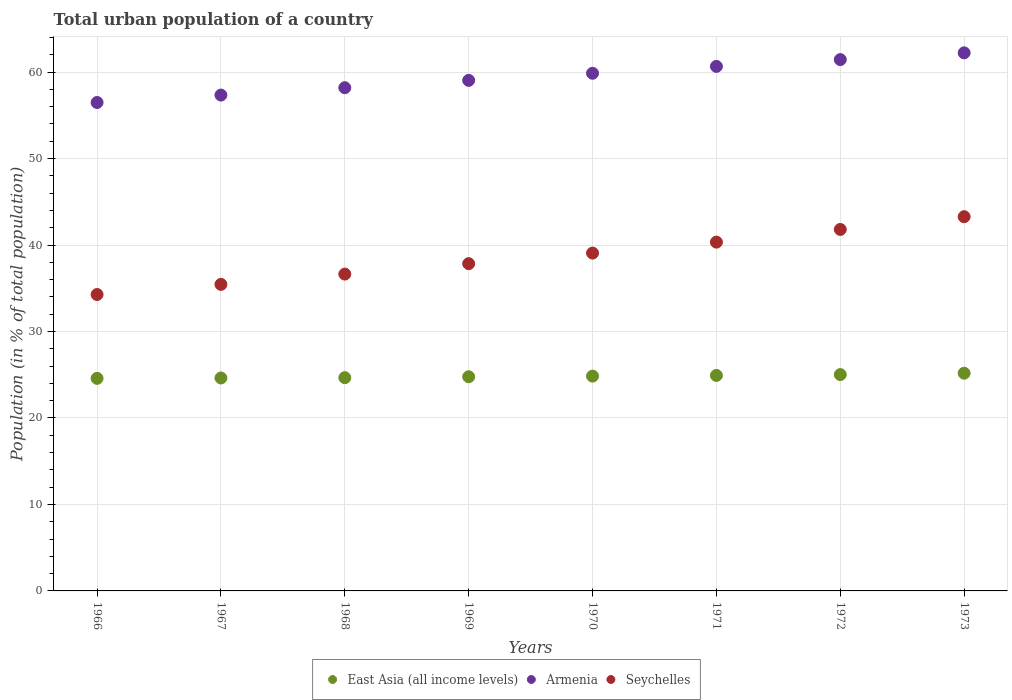How many different coloured dotlines are there?
Ensure brevity in your answer.  3. What is the urban population in Armenia in 1968?
Ensure brevity in your answer.  58.2. Across all years, what is the maximum urban population in Armenia?
Your answer should be very brief. 62.23. Across all years, what is the minimum urban population in Armenia?
Your answer should be compact. 56.48. In which year was the urban population in Seychelles maximum?
Ensure brevity in your answer.  1973. In which year was the urban population in Armenia minimum?
Your response must be concise. 1966. What is the total urban population in Seychelles in the graph?
Your answer should be compact. 308.7. What is the difference between the urban population in Seychelles in 1971 and that in 1972?
Give a very brief answer. -1.46. What is the difference between the urban population in Armenia in 1971 and the urban population in East Asia (all income levels) in 1968?
Offer a very short reply. 35.99. What is the average urban population in Seychelles per year?
Provide a succinct answer. 38.59. In the year 1970, what is the difference between the urban population in Seychelles and urban population in East Asia (all income levels)?
Offer a terse response. 14.23. In how many years, is the urban population in Seychelles greater than 48 %?
Your answer should be very brief. 0. What is the ratio of the urban population in Seychelles in 1967 to that in 1969?
Ensure brevity in your answer.  0.94. Is the urban population in Armenia in 1970 less than that in 1972?
Provide a succinct answer. Yes. What is the difference between the highest and the second highest urban population in Seychelles?
Your answer should be compact. 1.48. What is the difference between the highest and the lowest urban population in East Asia (all income levels)?
Make the answer very short. 0.59. In how many years, is the urban population in East Asia (all income levels) greater than the average urban population in East Asia (all income levels) taken over all years?
Your response must be concise. 4. Is the urban population in Seychelles strictly greater than the urban population in Armenia over the years?
Your response must be concise. No. Is the urban population in East Asia (all income levels) strictly less than the urban population in Armenia over the years?
Ensure brevity in your answer.  Yes. How many dotlines are there?
Provide a succinct answer. 3. How many years are there in the graph?
Your answer should be very brief. 8. What is the difference between two consecutive major ticks on the Y-axis?
Offer a terse response. 10. Does the graph contain any zero values?
Offer a terse response. No. How many legend labels are there?
Offer a very short reply. 3. What is the title of the graph?
Your response must be concise. Total urban population of a country. What is the label or title of the X-axis?
Provide a short and direct response. Years. What is the label or title of the Y-axis?
Offer a very short reply. Population (in % of total population). What is the Population (in % of total population) in East Asia (all income levels) in 1966?
Ensure brevity in your answer.  24.58. What is the Population (in % of total population) in Armenia in 1966?
Your response must be concise. 56.48. What is the Population (in % of total population) in Seychelles in 1966?
Give a very brief answer. 34.28. What is the Population (in % of total population) in East Asia (all income levels) in 1967?
Ensure brevity in your answer.  24.63. What is the Population (in % of total population) of Armenia in 1967?
Ensure brevity in your answer.  57.34. What is the Population (in % of total population) in Seychelles in 1967?
Your response must be concise. 35.45. What is the Population (in % of total population) in East Asia (all income levels) in 1968?
Provide a short and direct response. 24.66. What is the Population (in % of total population) in Armenia in 1968?
Keep it short and to the point. 58.2. What is the Population (in % of total population) in Seychelles in 1968?
Your answer should be compact. 36.64. What is the Population (in % of total population) of East Asia (all income levels) in 1969?
Provide a succinct answer. 24.77. What is the Population (in % of total population) of Armenia in 1969?
Provide a short and direct response. 59.04. What is the Population (in % of total population) of Seychelles in 1969?
Provide a succinct answer. 37.85. What is the Population (in % of total population) in East Asia (all income levels) in 1970?
Give a very brief answer. 24.84. What is the Population (in % of total population) of Armenia in 1970?
Offer a very short reply. 59.86. What is the Population (in % of total population) in Seychelles in 1970?
Ensure brevity in your answer.  39.07. What is the Population (in % of total population) of East Asia (all income levels) in 1971?
Provide a short and direct response. 24.92. What is the Population (in % of total population) of Armenia in 1971?
Ensure brevity in your answer.  60.66. What is the Population (in % of total population) in Seychelles in 1971?
Offer a terse response. 40.34. What is the Population (in % of total population) of East Asia (all income levels) in 1972?
Keep it short and to the point. 25.02. What is the Population (in % of total population) in Armenia in 1972?
Your response must be concise. 61.45. What is the Population (in % of total population) of Seychelles in 1972?
Give a very brief answer. 41.8. What is the Population (in % of total population) of East Asia (all income levels) in 1973?
Provide a succinct answer. 25.18. What is the Population (in % of total population) in Armenia in 1973?
Your answer should be compact. 62.23. What is the Population (in % of total population) of Seychelles in 1973?
Offer a terse response. 43.28. Across all years, what is the maximum Population (in % of total population) in East Asia (all income levels)?
Your response must be concise. 25.18. Across all years, what is the maximum Population (in % of total population) of Armenia?
Provide a short and direct response. 62.23. Across all years, what is the maximum Population (in % of total population) of Seychelles?
Your answer should be compact. 43.28. Across all years, what is the minimum Population (in % of total population) of East Asia (all income levels)?
Offer a very short reply. 24.58. Across all years, what is the minimum Population (in % of total population) in Armenia?
Make the answer very short. 56.48. Across all years, what is the minimum Population (in % of total population) of Seychelles?
Make the answer very short. 34.28. What is the total Population (in % of total population) in East Asia (all income levels) in the graph?
Your answer should be compact. 198.6. What is the total Population (in % of total population) of Armenia in the graph?
Offer a terse response. 475.25. What is the total Population (in % of total population) of Seychelles in the graph?
Your answer should be very brief. 308.7. What is the difference between the Population (in % of total population) of East Asia (all income levels) in 1966 and that in 1967?
Provide a succinct answer. -0.04. What is the difference between the Population (in % of total population) in Armenia in 1966 and that in 1967?
Provide a succinct answer. -0.86. What is the difference between the Population (in % of total population) of Seychelles in 1966 and that in 1967?
Your response must be concise. -1.17. What is the difference between the Population (in % of total population) of East Asia (all income levels) in 1966 and that in 1968?
Make the answer very short. -0.08. What is the difference between the Population (in % of total population) of Armenia in 1966 and that in 1968?
Give a very brief answer. -1.71. What is the difference between the Population (in % of total population) of Seychelles in 1966 and that in 1968?
Provide a succinct answer. -2.36. What is the difference between the Population (in % of total population) of East Asia (all income levels) in 1966 and that in 1969?
Make the answer very short. -0.19. What is the difference between the Population (in % of total population) of Armenia in 1966 and that in 1969?
Offer a very short reply. -2.56. What is the difference between the Population (in % of total population) in Seychelles in 1966 and that in 1969?
Your response must be concise. -3.57. What is the difference between the Population (in % of total population) in East Asia (all income levels) in 1966 and that in 1970?
Your answer should be very brief. -0.26. What is the difference between the Population (in % of total population) of Armenia in 1966 and that in 1970?
Keep it short and to the point. -3.38. What is the difference between the Population (in % of total population) in Seychelles in 1966 and that in 1970?
Your answer should be very brief. -4.79. What is the difference between the Population (in % of total population) in East Asia (all income levels) in 1966 and that in 1971?
Make the answer very short. -0.34. What is the difference between the Population (in % of total population) of Armenia in 1966 and that in 1971?
Your response must be concise. -4.17. What is the difference between the Population (in % of total population) in Seychelles in 1966 and that in 1971?
Provide a short and direct response. -6.06. What is the difference between the Population (in % of total population) of East Asia (all income levels) in 1966 and that in 1972?
Provide a short and direct response. -0.44. What is the difference between the Population (in % of total population) in Armenia in 1966 and that in 1972?
Provide a succinct answer. -4.96. What is the difference between the Population (in % of total population) in Seychelles in 1966 and that in 1972?
Provide a short and direct response. -7.53. What is the difference between the Population (in % of total population) of East Asia (all income levels) in 1966 and that in 1973?
Offer a very short reply. -0.59. What is the difference between the Population (in % of total population) of Armenia in 1966 and that in 1973?
Make the answer very short. -5.74. What is the difference between the Population (in % of total population) of East Asia (all income levels) in 1967 and that in 1968?
Make the answer very short. -0.04. What is the difference between the Population (in % of total population) of Armenia in 1967 and that in 1968?
Your response must be concise. -0.85. What is the difference between the Population (in % of total population) of Seychelles in 1967 and that in 1968?
Provide a succinct answer. -1.19. What is the difference between the Population (in % of total population) of East Asia (all income levels) in 1967 and that in 1969?
Your answer should be compact. -0.14. What is the difference between the Population (in % of total population) in Armenia in 1967 and that in 1969?
Your answer should be compact. -1.7. What is the difference between the Population (in % of total population) of Seychelles in 1967 and that in 1969?
Provide a succinct answer. -2.4. What is the difference between the Population (in % of total population) in East Asia (all income levels) in 1967 and that in 1970?
Keep it short and to the point. -0.21. What is the difference between the Population (in % of total population) of Armenia in 1967 and that in 1970?
Ensure brevity in your answer.  -2.52. What is the difference between the Population (in % of total population) in Seychelles in 1967 and that in 1970?
Provide a succinct answer. -3.62. What is the difference between the Population (in % of total population) of East Asia (all income levels) in 1967 and that in 1971?
Your answer should be compact. -0.29. What is the difference between the Population (in % of total population) of Armenia in 1967 and that in 1971?
Provide a succinct answer. -3.32. What is the difference between the Population (in % of total population) of Seychelles in 1967 and that in 1971?
Offer a terse response. -4.89. What is the difference between the Population (in % of total population) in East Asia (all income levels) in 1967 and that in 1972?
Provide a succinct answer. -0.39. What is the difference between the Population (in % of total population) of Armenia in 1967 and that in 1972?
Your answer should be very brief. -4.1. What is the difference between the Population (in % of total population) in Seychelles in 1967 and that in 1972?
Your answer should be very brief. -6.35. What is the difference between the Population (in % of total population) of East Asia (all income levels) in 1967 and that in 1973?
Make the answer very short. -0.55. What is the difference between the Population (in % of total population) in Armenia in 1967 and that in 1973?
Provide a succinct answer. -4.88. What is the difference between the Population (in % of total population) of Seychelles in 1967 and that in 1973?
Your answer should be compact. -7.83. What is the difference between the Population (in % of total population) of East Asia (all income levels) in 1968 and that in 1969?
Make the answer very short. -0.1. What is the difference between the Population (in % of total population) of Armenia in 1968 and that in 1969?
Give a very brief answer. -0.85. What is the difference between the Population (in % of total population) in Seychelles in 1968 and that in 1969?
Provide a succinct answer. -1.21. What is the difference between the Population (in % of total population) in East Asia (all income levels) in 1968 and that in 1970?
Make the answer very short. -0.18. What is the difference between the Population (in % of total population) of Armenia in 1968 and that in 1970?
Your response must be concise. -1.67. What is the difference between the Population (in % of total population) of Seychelles in 1968 and that in 1970?
Your response must be concise. -2.43. What is the difference between the Population (in % of total population) in East Asia (all income levels) in 1968 and that in 1971?
Provide a short and direct response. -0.26. What is the difference between the Population (in % of total population) in Armenia in 1968 and that in 1971?
Offer a very short reply. -2.46. What is the difference between the Population (in % of total population) in Seychelles in 1968 and that in 1971?
Ensure brevity in your answer.  -3.7. What is the difference between the Population (in % of total population) in East Asia (all income levels) in 1968 and that in 1972?
Make the answer very short. -0.36. What is the difference between the Population (in % of total population) in Armenia in 1968 and that in 1972?
Your answer should be compact. -3.25. What is the difference between the Population (in % of total population) of Seychelles in 1968 and that in 1972?
Your answer should be compact. -5.16. What is the difference between the Population (in % of total population) of East Asia (all income levels) in 1968 and that in 1973?
Give a very brief answer. -0.51. What is the difference between the Population (in % of total population) of Armenia in 1968 and that in 1973?
Your answer should be compact. -4.03. What is the difference between the Population (in % of total population) of Seychelles in 1968 and that in 1973?
Your answer should be very brief. -6.64. What is the difference between the Population (in % of total population) in East Asia (all income levels) in 1969 and that in 1970?
Offer a terse response. -0.07. What is the difference between the Population (in % of total population) in Armenia in 1969 and that in 1970?
Provide a succinct answer. -0.82. What is the difference between the Population (in % of total population) of Seychelles in 1969 and that in 1970?
Your answer should be compact. -1.22. What is the difference between the Population (in % of total population) of East Asia (all income levels) in 1969 and that in 1971?
Your answer should be compact. -0.15. What is the difference between the Population (in % of total population) in Armenia in 1969 and that in 1971?
Your answer should be compact. -1.61. What is the difference between the Population (in % of total population) of Seychelles in 1969 and that in 1971?
Offer a very short reply. -2.49. What is the difference between the Population (in % of total population) in East Asia (all income levels) in 1969 and that in 1972?
Keep it short and to the point. -0.25. What is the difference between the Population (in % of total population) in Armenia in 1969 and that in 1972?
Your answer should be compact. -2.4. What is the difference between the Population (in % of total population) of Seychelles in 1969 and that in 1972?
Keep it short and to the point. -3.96. What is the difference between the Population (in % of total population) in East Asia (all income levels) in 1969 and that in 1973?
Make the answer very short. -0.41. What is the difference between the Population (in % of total population) of Armenia in 1969 and that in 1973?
Give a very brief answer. -3.18. What is the difference between the Population (in % of total population) of Seychelles in 1969 and that in 1973?
Provide a succinct answer. -5.43. What is the difference between the Population (in % of total population) of East Asia (all income levels) in 1970 and that in 1971?
Offer a terse response. -0.08. What is the difference between the Population (in % of total population) in Armenia in 1970 and that in 1971?
Your answer should be very brief. -0.79. What is the difference between the Population (in % of total population) in Seychelles in 1970 and that in 1971?
Keep it short and to the point. -1.27. What is the difference between the Population (in % of total population) of East Asia (all income levels) in 1970 and that in 1972?
Give a very brief answer. -0.18. What is the difference between the Population (in % of total population) in Armenia in 1970 and that in 1972?
Your response must be concise. -1.58. What is the difference between the Population (in % of total population) in Seychelles in 1970 and that in 1972?
Offer a very short reply. -2.73. What is the difference between the Population (in % of total population) in East Asia (all income levels) in 1970 and that in 1973?
Make the answer very short. -0.34. What is the difference between the Population (in % of total population) in Armenia in 1970 and that in 1973?
Make the answer very short. -2.36. What is the difference between the Population (in % of total population) in Seychelles in 1970 and that in 1973?
Give a very brief answer. -4.21. What is the difference between the Population (in % of total population) in East Asia (all income levels) in 1971 and that in 1972?
Offer a terse response. -0.1. What is the difference between the Population (in % of total population) of Armenia in 1971 and that in 1972?
Your answer should be compact. -0.79. What is the difference between the Population (in % of total population) of Seychelles in 1971 and that in 1972?
Make the answer very short. -1.47. What is the difference between the Population (in % of total population) of East Asia (all income levels) in 1971 and that in 1973?
Your answer should be compact. -0.25. What is the difference between the Population (in % of total population) in Armenia in 1971 and that in 1973?
Give a very brief answer. -1.57. What is the difference between the Population (in % of total population) of Seychelles in 1971 and that in 1973?
Give a very brief answer. -2.94. What is the difference between the Population (in % of total population) in East Asia (all income levels) in 1972 and that in 1973?
Your response must be concise. -0.16. What is the difference between the Population (in % of total population) in Armenia in 1972 and that in 1973?
Offer a very short reply. -0.78. What is the difference between the Population (in % of total population) of Seychelles in 1972 and that in 1973?
Offer a terse response. -1.48. What is the difference between the Population (in % of total population) in East Asia (all income levels) in 1966 and the Population (in % of total population) in Armenia in 1967?
Make the answer very short. -32.76. What is the difference between the Population (in % of total population) of East Asia (all income levels) in 1966 and the Population (in % of total population) of Seychelles in 1967?
Offer a terse response. -10.87. What is the difference between the Population (in % of total population) of Armenia in 1966 and the Population (in % of total population) of Seychelles in 1967?
Your response must be concise. 21.03. What is the difference between the Population (in % of total population) of East Asia (all income levels) in 1966 and the Population (in % of total population) of Armenia in 1968?
Make the answer very short. -33.61. What is the difference between the Population (in % of total population) of East Asia (all income levels) in 1966 and the Population (in % of total population) of Seychelles in 1968?
Your answer should be very brief. -12.06. What is the difference between the Population (in % of total population) of Armenia in 1966 and the Population (in % of total population) of Seychelles in 1968?
Your response must be concise. 19.84. What is the difference between the Population (in % of total population) of East Asia (all income levels) in 1966 and the Population (in % of total population) of Armenia in 1969?
Ensure brevity in your answer.  -34.46. What is the difference between the Population (in % of total population) in East Asia (all income levels) in 1966 and the Population (in % of total population) in Seychelles in 1969?
Your response must be concise. -13.26. What is the difference between the Population (in % of total population) of Armenia in 1966 and the Population (in % of total population) of Seychelles in 1969?
Give a very brief answer. 18.64. What is the difference between the Population (in % of total population) in East Asia (all income levels) in 1966 and the Population (in % of total population) in Armenia in 1970?
Ensure brevity in your answer.  -35.28. What is the difference between the Population (in % of total population) of East Asia (all income levels) in 1966 and the Population (in % of total population) of Seychelles in 1970?
Offer a terse response. -14.49. What is the difference between the Population (in % of total population) of Armenia in 1966 and the Population (in % of total population) of Seychelles in 1970?
Provide a short and direct response. 17.41. What is the difference between the Population (in % of total population) of East Asia (all income levels) in 1966 and the Population (in % of total population) of Armenia in 1971?
Give a very brief answer. -36.07. What is the difference between the Population (in % of total population) of East Asia (all income levels) in 1966 and the Population (in % of total population) of Seychelles in 1971?
Keep it short and to the point. -15.75. What is the difference between the Population (in % of total population) in Armenia in 1966 and the Population (in % of total population) in Seychelles in 1971?
Your response must be concise. 16.15. What is the difference between the Population (in % of total population) in East Asia (all income levels) in 1966 and the Population (in % of total population) in Armenia in 1972?
Give a very brief answer. -36.86. What is the difference between the Population (in % of total population) in East Asia (all income levels) in 1966 and the Population (in % of total population) in Seychelles in 1972?
Ensure brevity in your answer.  -17.22. What is the difference between the Population (in % of total population) of Armenia in 1966 and the Population (in % of total population) of Seychelles in 1972?
Give a very brief answer. 14.68. What is the difference between the Population (in % of total population) of East Asia (all income levels) in 1966 and the Population (in % of total population) of Armenia in 1973?
Your answer should be very brief. -37.64. What is the difference between the Population (in % of total population) in East Asia (all income levels) in 1966 and the Population (in % of total population) in Seychelles in 1973?
Offer a very short reply. -18.69. What is the difference between the Population (in % of total population) in Armenia in 1966 and the Population (in % of total population) in Seychelles in 1973?
Provide a short and direct response. 13.21. What is the difference between the Population (in % of total population) of East Asia (all income levels) in 1967 and the Population (in % of total population) of Armenia in 1968?
Your answer should be compact. -33.57. What is the difference between the Population (in % of total population) in East Asia (all income levels) in 1967 and the Population (in % of total population) in Seychelles in 1968?
Ensure brevity in your answer.  -12.01. What is the difference between the Population (in % of total population) of Armenia in 1967 and the Population (in % of total population) of Seychelles in 1968?
Offer a terse response. 20.7. What is the difference between the Population (in % of total population) in East Asia (all income levels) in 1967 and the Population (in % of total population) in Armenia in 1969?
Provide a short and direct response. -34.42. What is the difference between the Population (in % of total population) of East Asia (all income levels) in 1967 and the Population (in % of total population) of Seychelles in 1969?
Provide a succinct answer. -13.22. What is the difference between the Population (in % of total population) of Armenia in 1967 and the Population (in % of total population) of Seychelles in 1969?
Ensure brevity in your answer.  19.5. What is the difference between the Population (in % of total population) in East Asia (all income levels) in 1967 and the Population (in % of total population) in Armenia in 1970?
Make the answer very short. -35.24. What is the difference between the Population (in % of total population) of East Asia (all income levels) in 1967 and the Population (in % of total population) of Seychelles in 1970?
Provide a succinct answer. -14.44. What is the difference between the Population (in % of total population) of Armenia in 1967 and the Population (in % of total population) of Seychelles in 1970?
Keep it short and to the point. 18.27. What is the difference between the Population (in % of total population) in East Asia (all income levels) in 1967 and the Population (in % of total population) in Armenia in 1971?
Give a very brief answer. -36.03. What is the difference between the Population (in % of total population) of East Asia (all income levels) in 1967 and the Population (in % of total population) of Seychelles in 1971?
Make the answer very short. -15.71. What is the difference between the Population (in % of total population) of Armenia in 1967 and the Population (in % of total population) of Seychelles in 1971?
Your answer should be compact. 17. What is the difference between the Population (in % of total population) of East Asia (all income levels) in 1967 and the Population (in % of total population) of Armenia in 1972?
Make the answer very short. -36.82. What is the difference between the Population (in % of total population) in East Asia (all income levels) in 1967 and the Population (in % of total population) in Seychelles in 1972?
Your response must be concise. -17.18. What is the difference between the Population (in % of total population) in Armenia in 1967 and the Population (in % of total population) in Seychelles in 1972?
Provide a short and direct response. 15.54. What is the difference between the Population (in % of total population) in East Asia (all income levels) in 1967 and the Population (in % of total population) in Armenia in 1973?
Your response must be concise. -37.6. What is the difference between the Population (in % of total population) in East Asia (all income levels) in 1967 and the Population (in % of total population) in Seychelles in 1973?
Make the answer very short. -18.65. What is the difference between the Population (in % of total population) of Armenia in 1967 and the Population (in % of total population) of Seychelles in 1973?
Offer a very short reply. 14.06. What is the difference between the Population (in % of total population) of East Asia (all income levels) in 1968 and the Population (in % of total population) of Armenia in 1969?
Provide a succinct answer. -34.38. What is the difference between the Population (in % of total population) in East Asia (all income levels) in 1968 and the Population (in % of total population) in Seychelles in 1969?
Offer a terse response. -13.18. What is the difference between the Population (in % of total population) in Armenia in 1968 and the Population (in % of total population) in Seychelles in 1969?
Ensure brevity in your answer.  20.35. What is the difference between the Population (in % of total population) of East Asia (all income levels) in 1968 and the Population (in % of total population) of Armenia in 1970?
Your response must be concise. -35.2. What is the difference between the Population (in % of total population) of East Asia (all income levels) in 1968 and the Population (in % of total population) of Seychelles in 1970?
Your answer should be very brief. -14.41. What is the difference between the Population (in % of total population) in Armenia in 1968 and the Population (in % of total population) in Seychelles in 1970?
Your response must be concise. 19.13. What is the difference between the Population (in % of total population) of East Asia (all income levels) in 1968 and the Population (in % of total population) of Armenia in 1971?
Your answer should be very brief. -35.99. What is the difference between the Population (in % of total population) in East Asia (all income levels) in 1968 and the Population (in % of total population) in Seychelles in 1971?
Ensure brevity in your answer.  -15.67. What is the difference between the Population (in % of total population) of Armenia in 1968 and the Population (in % of total population) of Seychelles in 1971?
Provide a succinct answer. 17.86. What is the difference between the Population (in % of total population) in East Asia (all income levels) in 1968 and the Population (in % of total population) in Armenia in 1972?
Offer a very short reply. -36.78. What is the difference between the Population (in % of total population) in East Asia (all income levels) in 1968 and the Population (in % of total population) in Seychelles in 1972?
Make the answer very short. -17.14. What is the difference between the Population (in % of total population) of Armenia in 1968 and the Population (in % of total population) of Seychelles in 1972?
Provide a succinct answer. 16.39. What is the difference between the Population (in % of total population) of East Asia (all income levels) in 1968 and the Population (in % of total population) of Armenia in 1973?
Offer a terse response. -37.56. What is the difference between the Population (in % of total population) of East Asia (all income levels) in 1968 and the Population (in % of total population) of Seychelles in 1973?
Make the answer very short. -18.61. What is the difference between the Population (in % of total population) of Armenia in 1968 and the Population (in % of total population) of Seychelles in 1973?
Provide a succinct answer. 14.92. What is the difference between the Population (in % of total population) in East Asia (all income levels) in 1969 and the Population (in % of total population) in Armenia in 1970?
Ensure brevity in your answer.  -35.1. What is the difference between the Population (in % of total population) in East Asia (all income levels) in 1969 and the Population (in % of total population) in Seychelles in 1970?
Give a very brief answer. -14.3. What is the difference between the Population (in % of total population) of Armenia in 1969 and the Population (in % of total population) of Seychelles in 1970?
Ensure brevity in your answer.  19.97. What is the difference between the Population (in % of total population) in East Asia (all income levels) in 1969 and the Population (in % of total population) in Armenia in 1971?
Keep it short and to the point. -35.89. What is the difference between the Population (in % of total population) of East Asia (all income levels) in 1969 and the Population (in % of total population) of Seychelles in 1971?
Make the answer very short. -15.57. What is the difference between the Population (in % of total population) in Armenia in 1969 and the Population (in % of total population) in Seychelles in 1971?
Ensure brevity in your answer.  18.7. What is the difference between the Population (in % of total population) of East Asia (all income levels) in 1969 and the Population (in % of total population) of Armenia in 1972?
Your answer should be compact. -36.68. What is the difference between the Population (in % of total population) in East Asia (all income levels) in 1969 and the Population (in % of total population) in Seychelles in 1972?
Give a very brief answer. -17.03. What is the difference between the Population (in % of total population) in Armenia in 1969 and the Population (in % of total population) in Seychelles in 1972?
Offer a very short reply. 17.24. What is the difference between the Population (in % of total population) in East Asia (all income levels) in 1969 and the Population (in % of total population) in Armenia in 1973?
Ensure brevity in your answer.  -37.46. What is the difference between the Population (in % of total population) of East Asia (all income levels) in 1969 and the Population (in % of total population) of Seychelles in 1973?
Ensure brevity in your answer.  -18.51. What is the difference between the Population (in % of total population) in Armenia in 1969 and the Population (in % of total population) in Seychelles in 1973?
Your answer should be compact. 15.77. What is the difference between the Population (in % of total population) of East Asia (all income levels) in 1970 and the Population (in % of total population) of Armenia in 1971?
Provide a succinct answer. -35.82. What is the difference between the Population (in % of total population) in East Asia (all income levels) in 1970 and the Population (in % of total population) in Seychelles in 1971?
Provide a succinct answer. -15.5. What is the difference between the Population (in % of total population) in Armenia in 1970 and the Population (in % of total population) in Seychelles in 1971?
Provide a succinct answer. 19.53. What is the difference between the Population (in % of total population) of East Asia (all income levels) in 1970 and the Population (in % of total population) of Armenia in 1972?
Provide a succinct answer. -36.6. What is the difference between the Population (in % of total population) in East Asia (all income levels) in 1970 and the Population (in % of total population) in Seychelles in 1972?
Offer a very short reply. -16.96. What is the difference between the Population (in % of total population) in Armenia in 1970 and the Population (in % of total population) in Seychelles in 1972?
Your answer should be very brief. 18.06. What is the difference between the Population (in % of total population) of East Asia (all income levels) in 1970 and the Population (in % of total population) of Armenia in 1973?
Give a very brief answer. -37.38. What is the difference between the Population (in % of total population) of East Asia (all income levels) in 1970 and the Population (in % of total population) of Seychelles in 1973?
Ensure brevity in your answer.  -18.44. What is the difference between the Population (in % of total population) of Armenia in 1970 and the Population (in % of total population) of Seychelles in 1973?
Give a very brief answer. 16.59. What is the difference between the Population (in % of total population) of East Asia (all income levels) in 1971 and the Population (in % of total population) of Armenia in 1972?
Offer a very short reply. -36.52. What is the difference between the Population (in % of total population) in East Asia (all income levels) in 1971 and the Population (in % of total population) in Seychelles in 1972?
Offer a very short reply. -16.88. What is the difference between the Population (in % of total population) in Armenia in 1971 and the Population (in % of total population) in Seychelles in 1972?
Ensure brevity in your answer.  18.86. What is the difference between the Population (in % of total population) of East Asia (all income levels) in 1971 and the Population (in % of total population) of Armenia in 1973?
Provide a succinct answer. -37.3. What is the difference between the Population (in % of total population) of East Asia (all income levels) in 1971 and the Population (in % of total population) of Seychelles in 1973?
Make the answer very short. -18.36. What is the difference between the Population (in % of total population) in Armenia in 1971 and the Population (in % of total population) in Seychelles in 1973?
Offer a terse response. 17.38. What is the difference between the Population (in % of total population) in East Asia (all income levels) in 1972 and the Population (in % of total population) in Armenia in 1973?
Your answer should be very brief. -37.21. What is the difference between the Population (in % of total population) of East Asia (all income levels) in 1972 and the Population (in % of total population) of Seychelles in 1973?
Offer a very short reply. -18.26. What is the difference between the Population (in % of total population) of Armenia in 1972 and the Population (in % of total population) of Seychelles in 1973?
Your response must be concise. 18.17. What is the average Population (in % of total population) of East Asia (all income levels) per year?
Offer a terse response. 24.82. What is the average Population (in % of total population) of Armenia per year?
Ensure brevity in your answer.  59.41. What is the average Population (in % of total population) of Seychelles per year?
Make the answer very short. 38.59. In the year 1966, what is the difference between the Population (in % of total population) of East Asia (all income levels) and Population (in % of total population) of Armenia?
Keep it short and to the point. -31.9. In the year 1966, what is the difference between the Population (in % of total population) in East Asia (all income levels) and Population (in % of total population) in Seychelles?
Keep it short and to the point. -9.69. In the year 1966, what is the difference between the Population (in % of total population) in Armenia and Population (in % of total population) in Seychelles?
Your answer should be very brief. 22.21. In the year 1967, what is the difference between the Population (in % of total population) of East Asia (all income levels) and Population (in % of total population) of Armenia?
Provide a short and direct response. -32.71. In the year 1967, what is the difference between the Population (in % of total population) in East Asia (all income levels) and Population (in % of total population) in Seychelles?
Offer a very short reply. -10.82. In the year 1967, what is the difference between the Population (in % of total population) in Armenia and Population (in % of total population) in Seychelles?
Offer a terse response. 21.89. In the year 1968, what is the difference between the Population (in % of total population) in East Asia (all income levels) and Population (in % of total population) in Armenia?
Your answer should be very brief. -33.53. In the year 1968, what is the difference between the Population (in % of total population) of East Asia (all income levels) and Population (in % of total population) of Seychelles?
Provide a short and direct response. -11.98. In the year 1968, what is the difference between the Population (in % of total population) in Armenia and Population (in % of total population) in Seychelles?
Make the answer very short. 21.55. In the year 1969, what is the difference between the Population (in % of total population) of East Asia (all income levels) and Population (in % of total population) of Armenia?
Make the answer very short. -34.27. In the year 1969, what is the difference between the Population (in % of total population) of East Asia (all income levels) and Population (in % of total population) of Seychelles?
Ensure brevity in your answer.  -13.08. In the year 1969, what is the difference between the Population (in % of total population) of Armenia and Population (in % of total population) of Seychelles?
Give a very brief answer. 21.2. In the year 1970, what is the difference between the Population (in % of total population) of East Asia (all income levels) and Population (in % of total population) of Armenia?
Make the answer very short. -35.02. In the year 1970, what is the difference between the Population (in % of total population) of East Asia (all income levels) and Population (in % of total population) of Seychelles?
Offer a terse response. -14.23. In the year 1970, what is the difference between the Population (in % of total population) in Armenia and Population (in % of total population) in Seychelles?
Offer a very short reply. 20.8. In the year 1971, what is the difference between the Population (in % of total population) of East Asia (all income levels) and Population (in % of total population) of Armenia?
Offer a very short reply. -35.74. In the year 1971, what is the difference between the Population (in % of total population) of East Asia (all income levels) and Population (in % of total population) of Seychelles?
Your response must be concise. -15.42. In the year 1971, what is the difference between the Population (in % of total population) of Armenia and Population (in % of total population) of Seychelles?
Provide a succinct answer. 20.32. In the year 1972, what is the difference between the Population (in % of total population) of East Asia (all income levels) and Population (in % of total population) of Armenia?
Give a very brief answer. -36.43. In the year 1972, what is the difference between the Population (in % of total population) in East Asia (all income levels) and Population (in % of total population) in Seychelles?
Give a very brief answer. -16.78. In the year 1972, what is the difference between the Population (in % of total population) of Armenia and Population (in % of total population) of Seychelles?
Give a very brief answer. 19.64. In the year 1973, what is the difference between the Population (in % of total population) in East Asia (all income levels) and Population (in % of total population) in Armenia?
Your answer should be very brief. -37.05. In the year 1973, what is the difference between the Population (in % of total population) of East Asia (all income levels) and Population (in % of total population) of Seychelles?
Your answer should be very brief. -18.1. In the year 1973, what is the difference between the Population (in % of total population) of Armenia and Population (in % of total population) of Seychelles?
Your response must be concise. 18.95. What is the ratio of the Population (in % of total population) in Armenia in 1966 to that in 1967?
Make the answer very short. 0.98. What is the ratio of the Population (in % of total population) in Seychelles in 1966 to that in 1967?
Make the answer very short. 0.97. What is the ratio of the Population (in % of total population) in Armenia in 1966 to that in 1968?
Ensure brevity in your answer.  0.97. What is the ratio of the Population (in % of total population) in Seychelles in 1966 to that in 1968?
Keep it short and to the point. 0.94. What is the ratio of the Population (in % of total population) of East Asia (all income levels) in 1966 to that in 1969?
Offer a terse response. 0.99. What is the ratio of the Population (in % of total population) of Armenia in 1966 to that in 1969?
Your answer should be compact. 0.96. What is the ratio of the Population (in % of total population) of Seychelles in 1966 to that in 1969?
Ensure brevity in your answer.  0.91. What is the ratio of the Population (in % of total population) of East Asia (all income levels) in 1966 to that in 1970?
Give a very brief answer. 0.99. What is the ratio of the Population (in % of total population) in Armenia in 1966 to that in 1970?
Make the answer very short. 0.94. What is the ratio of the Population (in % of total population) in Seychelles in 1966 to that in 1970?
Your answer should be very brief. 0.88. What is the ratio of the Population (in % of total population) in East Asia (all income levels) in 1966 to that in 1971?
Give a very brief answer. 0.99. What is the ratio of the Population (in % of total population) of Armenia in 1966 to that in 1971?
Provide a short and direct response. 0.93. What is the ratio of the Population (in % of total population) in Seychelles in 1966 to that in 1971?
Your answer should be very brief. 0.85. What is the ratio of the Population (in % of total population) of East Asia (all income levels) in 1966 to that in 1972?
Keep it short and to the point. 0.98. What is the ratio of the Population (in % of total population) of Armenia in 1966 to that in 1972?
Offer a very short reply. 0.92. What is the ratio of the Population (in % of total population) in Seychelles in 1966 to that in 1972?
Your response must be concise. 0.82. What is the ratio of the Population (in % of total population) of East Asia (all income levels) in 1966 to that in 1973?
Your answer should be compact. 0.98. What is the ratio of the Population (in % of total population) in Armenia in 1966 to that in 1973?
Offer a terse response. 0.91. What is the ratio of the Population (in % of total population) in Seychelles in 1966 to that in 1973?
Keep it short and to the point. 0.79. What is the ratio of the Population (in % of total population) in East Asia (all income levels) in 1967 to that in 1968?
Provide a short and direct response. 1. What is the ratio of the Population (in % of total population) of Armenia in 1967 to that in 1968?
Provide a short and direct response. 0.99. What is the ratio of the Population (in % of total population) of Seychelles in 1967 to that in 1968?
Offer a terse response. 0.97. What is the ratio of the Population (in % of total population) in Armenia in 1967 to that in 1969?
Your answer should be very brief. 0.97. What is the ratio of the Population (in % of total population) of Seychelles in 1967 to that in 1969?
Provide a succinct answer. 0.94. What is the ratio of the Population (in % of total population) of East Asia (all income levels) in 1967 to that in 1970?
Offer a terse response. 0.99. What is the ratio of the Population (in % of total population) in Armenia in 1967 to that in 1970?
Give a very brief answer. 0.96. What is the ratio of the Population (in % of total population) of Seychelles in 1967 to that in 1970?
Give a very brief answer. 0.91. What is the ratio of the Population (in % of total population) of Armenia in 1967 to that in 1971?
Your answer should be very brief. 0.95. What is the ratio of the Population (in % of total population) in Seychelles in 1967 to that in 1971?
Give a very brief answer. 0.88. What is the ratio of the Population (in % of total population) in East Asia (all income levels) in 1967 to that in 1972?
Provide a succinct answer. 0.98. What is the ratio of the Population (in % of total population) in Armenia in 1967 to that in 1972?
Ensure brevity in your answer.  0.93. What is the ratio of the Population (in % of total population) of Seychelles in 1967 to that in 1972?
Give a very brief answer. 0.85. What is the ratio of the Population (in % of total population) of East Asia (all income levels) in 1967 to that in 1973?
Provide a succinct answer. 0.98. What is the ratio of the Population (in % of total population) in Armenia in 1967 to that in 1973?
Provide a short and direct response. 0.92. What is the ratio of the Population (in % of total population) in Seychelles in 1967 to that in 1973?
Provide a short and direct response. 0.82. What is the ratio of the Population (in % of total population) of Armenia in 1968 to that in 1969?
Give a very brief answer. 0.99. What is the ratio of the Population (in % of total population) of Seychelles in 1968 to that in 1969?
Give a very brief answer. 0.97. What is the ratio of the Population (in % of total population) in Armenia in 1968 to that in 1970?
Make the answer very short. 0.97. What is the ratio of the Population (in % of total population) in Seychelles in 1968 to that in 1970?
Keep it short and to the point. 0.94. What is the ratio of the Population (in % of total population) of East Asia (all income levels) in 1968 to that in 1971?
Ensure brevity in your answer.  0.99. What is the ratio of the Population (in % of total population) of Armenia in 1968 to that in 1971?
Your answer should be compact. 0.96. What is the ratio of the Population (in % of total population) in Seychelles in 1968 to that in 1971?
Give a very brief answer. 0.91. What is the ratio of the Population (in % of total population) of East Asia (all income levels) in 1968 to that in 1972?
Give a very brief answer. 0.99. What is the ratio of the Population (in % of total population) in Armenia in 1968 to that in 1972?
Give a very brief answer. 0.95. What is the ratio of the Population (in % of total population) of Seychelles in 1968 to that in 1972?
Your answer should be very brief. 0.88. What is the ratio of the Population (in % of total population) of East Asia (all income levels) in 1968 to that in 1973?
Keep it short and to the point. 0.98. What is the ratio of the Population (in % of total population) of Armenia in 1968 to that in 1973?
Provide a short and direct response. 0.94. What is the ratio of the Population (in % of total population) in Seychelles in 1968 to that in 1973?
Offer a terse response. 0.85. What is the ratio of the Population (in % of total population) of East Asia (all income levels) in 1969 to that in 1970?
Your response must be concise. 1. What is the ratio of the Population (in % of total population) in Armenia in 1969 to that in 1970?
Your response must be concise. 0.99. What is the ratio of the Population (in % of total population) in Seychelles in 1969 to that in 1970?
Provide a short and direct response. 0.97. What is the ratio of the Population (in % of total population) in Armenia in 1969 to that in 1971?
Your response must be concise. 0.97. What is the ratio of the Population (in % of total population) of Seychelles in 1969 to that in 1971?
Provide a short and direct response. 0.94. What is the ratio of the Population (in % of total population) of Armenia in 1969 to that in 1972?
Provide a short and direct response. 0.96. What is the ratio of the Population (in % of total population) of Seychelles in 1969 to that in 1972?
Offer a very short reply. 0.91. What is the ratio of the Population (in % of total population) in East Asia (all income levels) in 1969 to that in 1973?
Offer a terse response. 0.98. What is the ratio of the Population (in % of total population) in Armenia in 1969 to that in 1973?
Give a very brief answer. 0.95. What is the ratio of the Population (in % of total population) of Seychelles in 1969 to that in 1973?
Provide a succinct answer. 0.87. What is the ratio of the Population (in % of total population) of East Asia (all income levels) in 1970 to that in 1971?
Ensure brevity in your answer.  1. What is the ratio of the Population (in % of total population) in Armenia in 1970 to that in 1971?
Provide a short and direct response. 0.99. What is the ratio of the Population (in % of total population) of Seychelles in 1970 to that in 1971?
Keep it short and to the point. 0.97. What is the ratio of the Population (in % of total population) in East Asia (all income levels) in 1970 to that in 1972?
Provide a succinct answer. 0.99. What is the ratio of the Population (in % of total population) of Armenia in 1970 to that in 1972?
Your answer should be compact. 0.97. What is the ratio of the Population (in % of total population) in Seychelles in 1970 to that in 1972?
Give a very brief answer. 0.93. What is the ratio of the Population (in % of total population) in East Asia (all income levels) in 1970 to that in 1973?
Give a very brief answer. 0.99. What is the ratio of the Population (in % of total population) of Armenia in 1970 to that in 1973?
Provide a short and direct response. 0.96. What is the ratio of the Population (in % of total population) in Seychelles in 1970 to that in 1973?
Offer a very short reply. 0.9. What is the ratio of the Population (in % of total population) of East Asia (all income levels) in 1971 to that in 1972?
Offer a terse response. 1. What is the ratio of the Population (in % of total population) of Armenia in 1971 to that in 1972?
Give a very brief answer. 0.99. What is the ratio of the Population (in % of total population) of Seychelles in 1971 to that in 1972?
Offer a terse response. 0.96. What is the ratio of the Population (in % of total population) of East Asia (all income levels) in 1971 to that in 1973?
Make the answer very short. 0.99. What is the ratio of the Population (in % of total population) in Armenia in 1971 to that in 1973?
Provide a short and direct response. 0.97. What is the ratio of the Population (in % of total population) in Seychelles in 1971 to that in 1973?
Your response must be concise. 0.93. What is the ratio of the Population (in % of total population) in East Asia (all income levels) in 1972 to that in 1973?
Offer a terse response. 0.99. What is the ratio of the Population (in % of total population) in Armenia in 1972 to that in 1973?
Your response must be concise. 0.99. What is the ratio of the Population (in % of total population) of Seychelles in 1972 to that in 1973?
Ensure brevity in your answer.  0.97. What is the difference between the highest and the second highest Population (in % of total population) of East Asia (all income levels)?
Ensure brevity in your answer.  0.16. What is the difference between the highest and the second highest Population (in % of total population) in Armenia?
Your answer should be very brief. 0.78. What is the difference between the highest and the second highest Population (in % of total population) of Seychelles?
Provide a short and direct response. 1.48. What is the difference between the highest and the lowest Population (in % of total population) in East Asia (all income levels)?
Ensure brevity in your answer.  0.59. What is the difference between the highest and the lowest Population (in % of total population) of Armenia?
Provide a short and direct response. 5.74. What is the difference between the highest and the lowest Population (in % of total population) of Seychelles?
Provide a succinct answer. 9. 